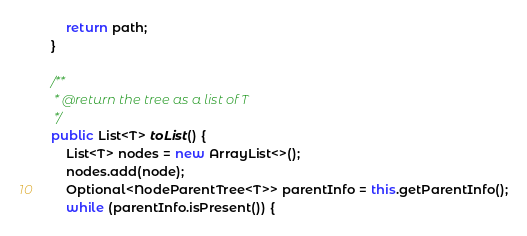<code> <loc_0><loc_0><loc_500><loc_500><_Java_>        return path;
    }

    /**
     * @return the tree as a list of T
     */
    public List<T> toList() {
        List<T> nodes = new ArrayList<>();
        nodes.add(node);
        Optional<NodeParentTree<T>> parentInfo = this.getParentInfo();
        while (parentInfo.isPresent()) {</code> 